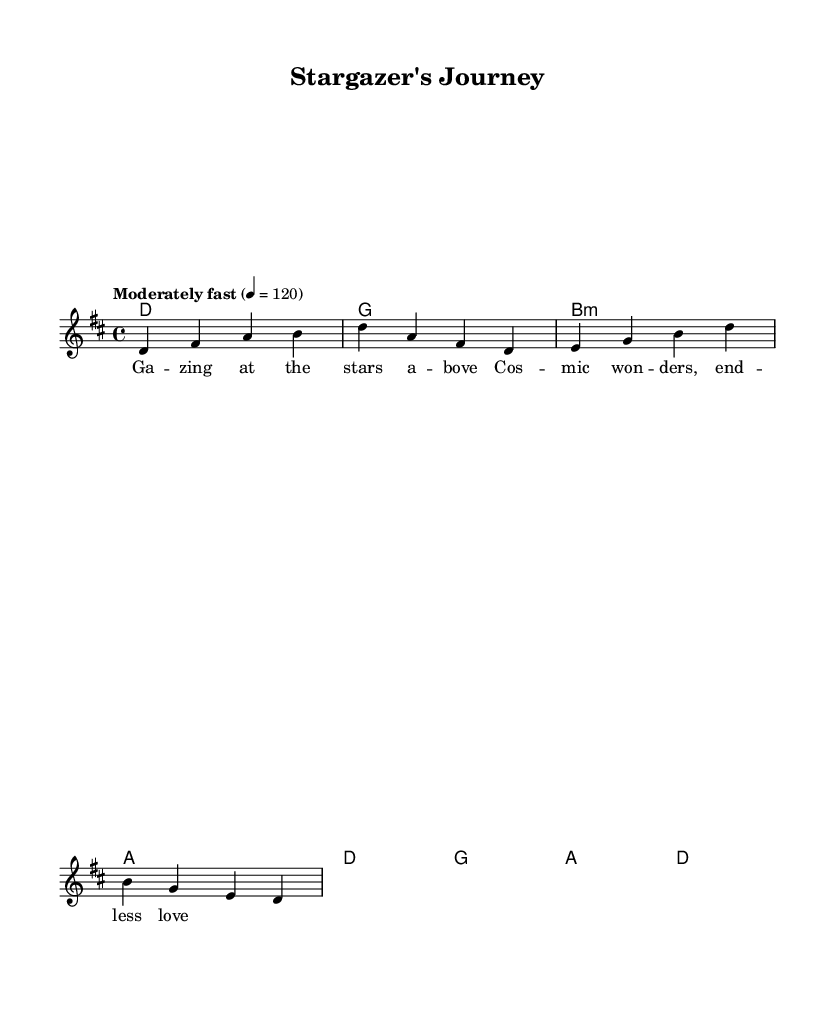What is the key signature of this music? The key signature is D major, which has two sharps (F# and C#) indicated at the beginning of the staff.
Answer: D major What is the time signature of this music? The time signature is 4/4, which means each measure has four beats, and the quarter note receives one beat. This is indicated at the beginning of the music sheet.
Answer: 4/4 What is the tempo marking of this piece? The tempo marking is "Moderately fast" with a metronome setting of 120 beats per minute, showing how fast the music should be played.
Answer: Moderately fast How many measures are in the melody section? The melody section consists of four measures, as indicated by the grouping of notes and the bar lines which separate each measure.
Answer: 4 What is the structure of the lyrics in this music? The lyrics follow a simple two-line structure, containing a rhyme that highlights the themes of cosmic wonder and beauty.
Answer: Two-line rhyme What type of chords are used in the harmony section? The harmony section primarily consists of major chords, which are indicative of the folk genre's characteristic sound and uplifting nature, exemplified by D and G major chords.
Answer: Major chords Which thematic element does the song emphasize? The song emphasizes stargazing and cosmic wonder, reflecting feelings of awe and love for the universe as expressed through the lyrics and melody.
Answer: Stargazing and cosmic wonder 